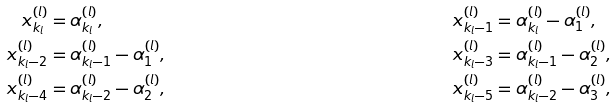Convert formula to latex. <formula><loc_0><loc_0><loc_500><loc_500>x _ { k _ { l } } ^ { ( l ) } & = \alpha _ { k _ { l } } ^ { ( l ) } , & x _ { k _ { l } - 1 } ^ { ( l ) } & = \alpha _ { k _ { l } } ^ { ( l ) } - \alpha _ { 1 } ^ { ( l ) } , \\ x _ { k _ { l } - 2 } ^ { ( l ) } & = \alpha _ { k _ { l } - 1 } ^ { ( l ) } - \alpha _ { 1 } ^ { ( l ) } , & x _ { k _ { l } - 3 } ^ { ( l ) } & = \alpha _ { k _ { l } - 1 } ^ { ( l ) } - \alpha _ { 2 } ^ { ( l ) } , \\ x _ { k _ { l } - 4 } ^ { ( l ) } & = \alpha _ { k _ { l } - 2 } ^ { ( l ) } - \alpha _ { 2 } ^ { ( l ) } , & x _ { k _ { l } - 5 } ^ { ( l ) } & = \alpha _ { k _ { l } - 2 } ^ { ( l ) } - \alpha _ { 3 } ^ { ( l ) } ,</formula> 